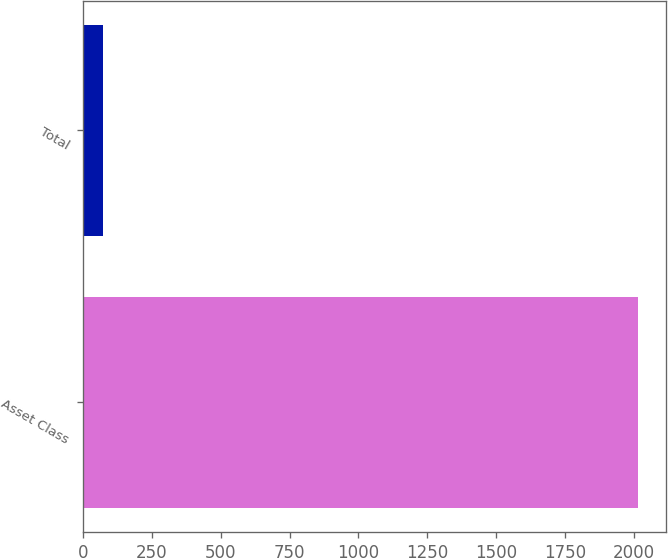Convert chart to OTSL. <chart><loc_0><loc_0><loc_500><loc_500><bar_chart><fcel>Asset Class<fcel>Total<nl><fcel>2014<fcel>74<nl></chart> 